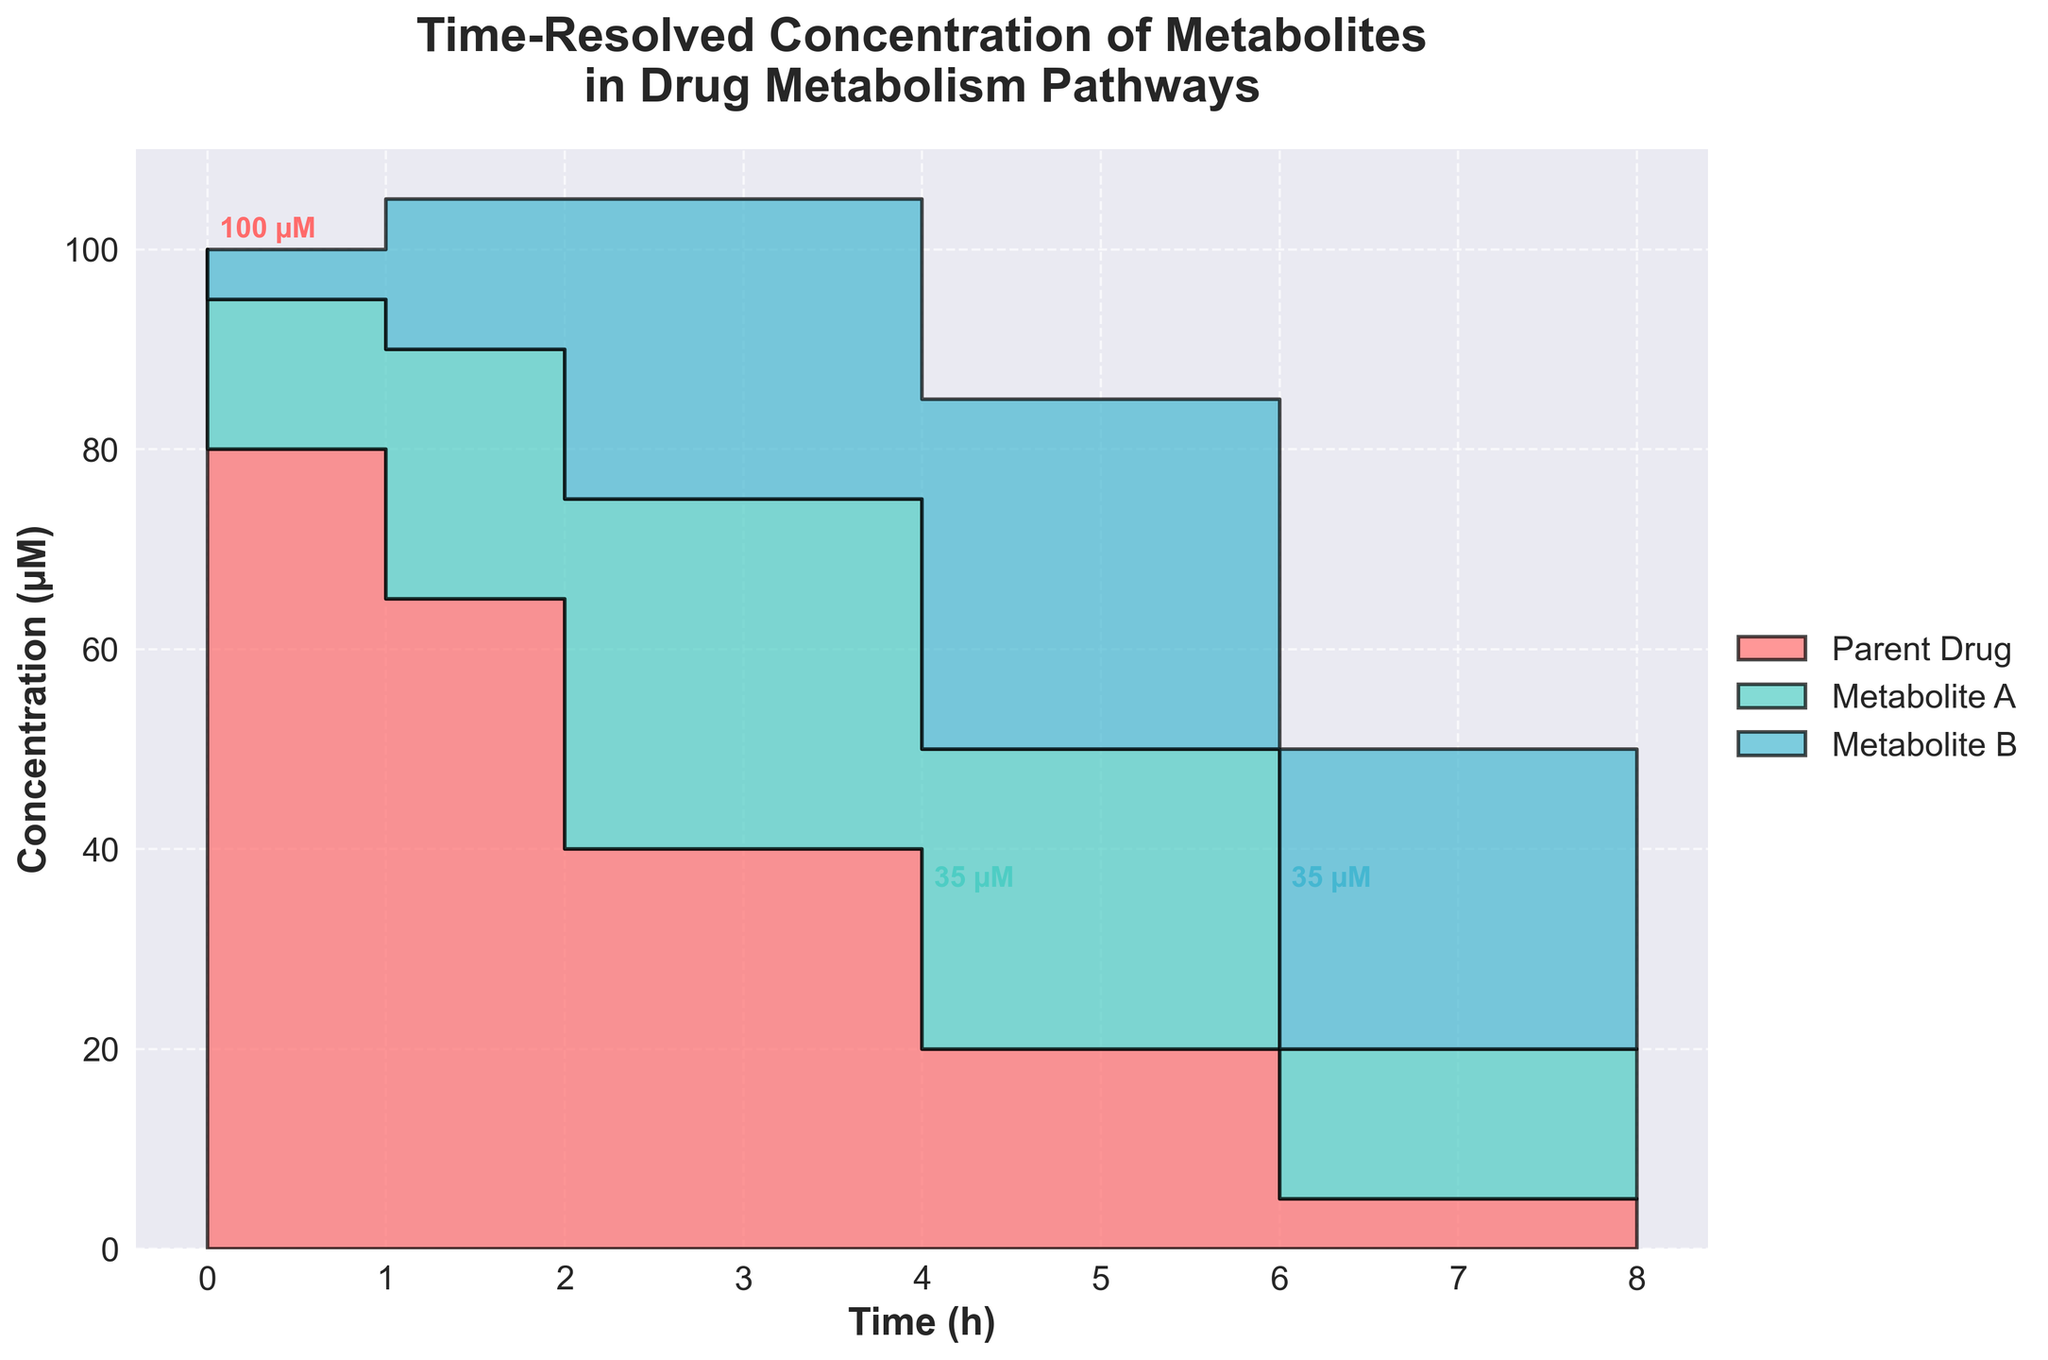What is the title of the figure? The title is located at the top of the plot, in bold, larger font text.
Answer: Time-Resolved Concentration of Metabolites in Drug Metabolism Pathways How many unique metabolites are plotted in the figure? The different colored shaded areas represent different metabolites. The legend on the right side indicates the names of the metabolites.
Answer: Three What time point shows the highest concentration for Metabolite B? By observing the Metabolite B's step area and noting the annotated peak concentration, the highest point is found at the corresponding time.
Answer: 6 hours Which metabolite has the steepest drop in concentration after reaching its peak? Compare the slopes of the decline in concentrations for all metabolites. Steepness can be assessed by visually comparing the gradients of the step areas.
Answer: Parent Drug At what time do all metabolites sum up to an approximate total concentration of 100 µM? By visually summing up the heights (y-values) of the shaded areas at each time point, find where they approximate 100 µM. This involves looking across the entire plot and comparing the sums.
Answer: 4 hours What is the difference in concentration between Metabolite A and Metabolite B at 2 hours? Locate the concentrations at 2 hours for both metabolites and subtract the smaller from the larger value. Metabolite A is 25 µM, and Metabolite B is 15 µM.
Answer: 10 µM What trend in concentration is observed for the Parent Drug over time? Observe the shape of the step area for the Parent Drug. The generally decreasing trend indicates that as time progresses, its concentration drops.
Answer: Decreasing trend Which metabolite reaches its peak concentration the earliest? Look at each annotated highest concentration point and identify which occurs first along the x-axis.
Answer: Metabolite A How does the total concentration of all metabolites change from 0 to 8 hours? Sum the heights (y-values) of all step areas at the start and at the end. Initially, the sum is the Parent Drug at 100 µM. By 8 hours, summing all metabolites' concentrations yields a lower total. This is a decline in total concentration.
Answer: Decreases 